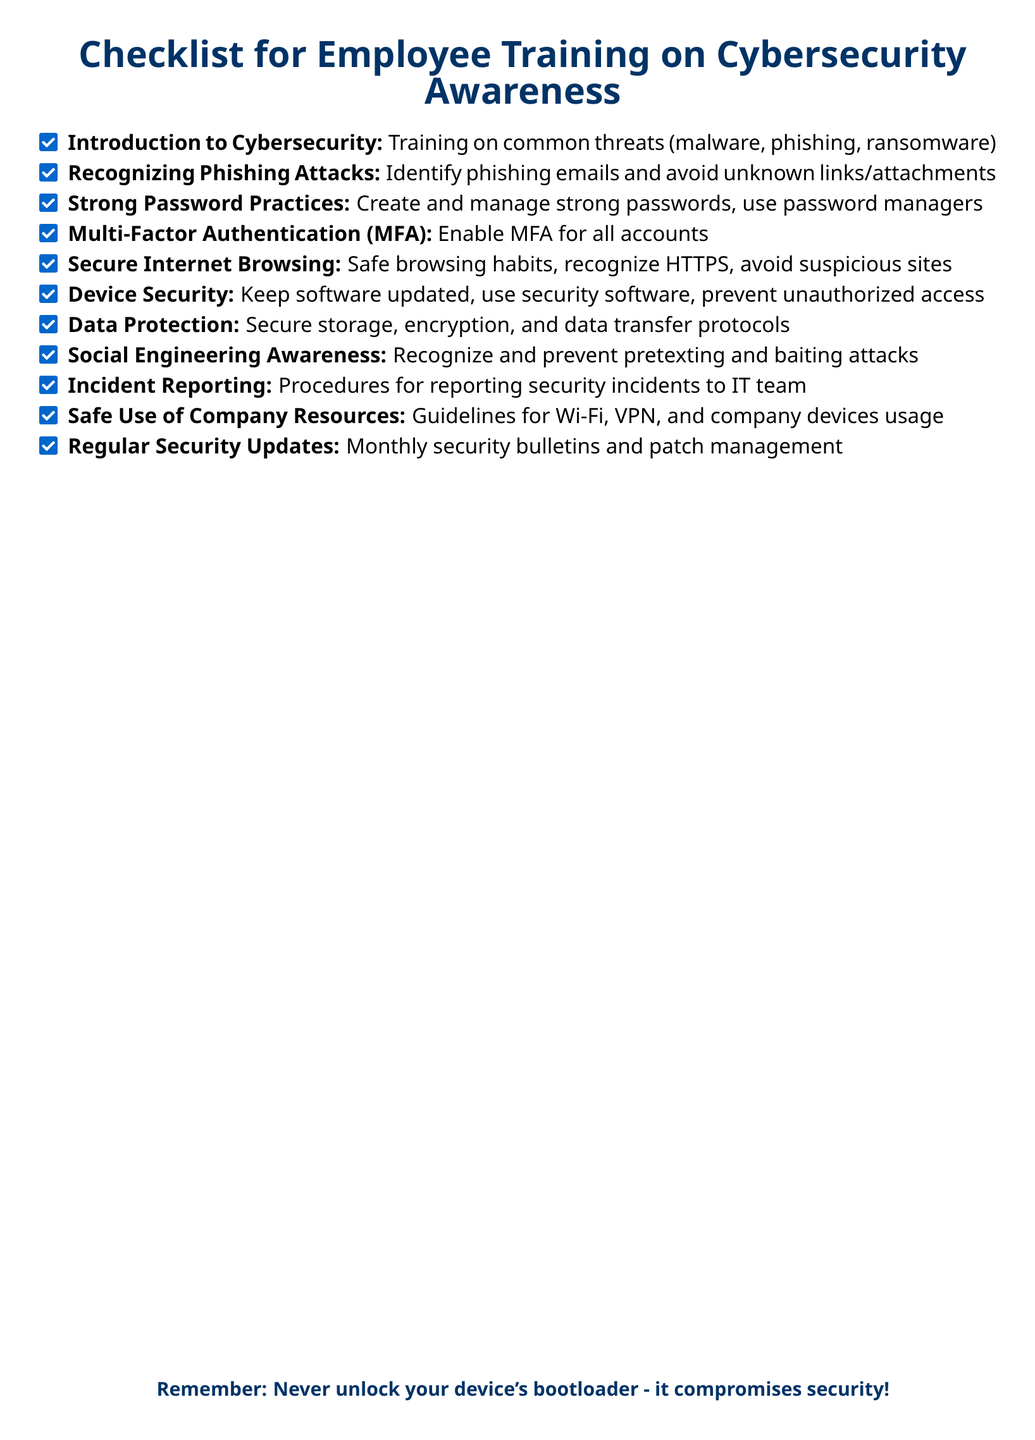What is the title of the document? The title is prominently displayed at the top of the document in a larger font, serving as a header.
Answer: Checklist for Employee Training on Cybersecurity Awareness How many items are listed in the checklist? The number of items in the checklist can be counted directly from the list provided in the document.
Answer: 11 What should employees do to enhance password security? The document includes guidelines for password management under a specific checklist item related to passwords.
Answer: Use password managers What is emphasized at the bottom of the document regarding device security? The bottom section of the document includes a reminder about security, particularly related to devices.
Answer: Never unlock your device's bootloader Which practice is recommended for all accounts? The document advises a specific security measure for protecting accounts within the checklist.
Answer: Enable MFA 